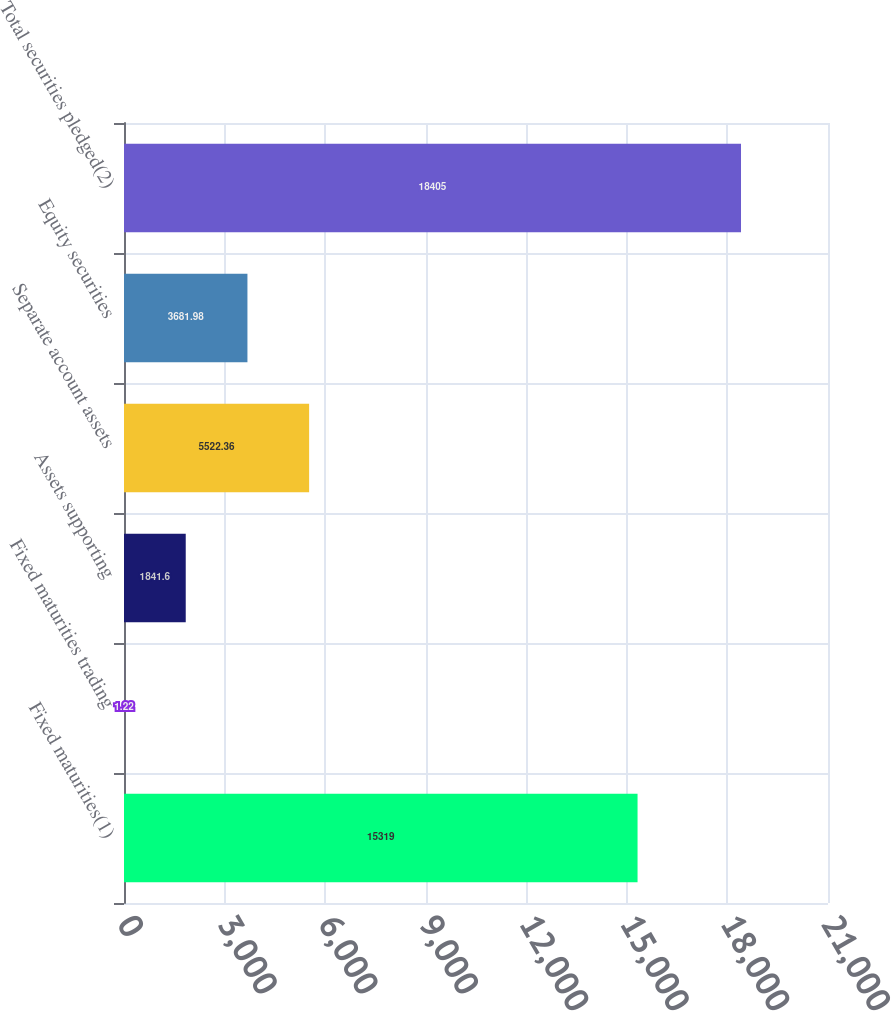Convert chart. <chart><loc_0><loc_0><loc_500><loc_500><bar_chart><fcel>Fixed maturities(1)<fcel>Fixed maturities trading<fcel>Assets supporting<fcel>Separate account assets<fcel>Equity securities<fcel>Total securities pledged(2)<nl><fcel>15319<fcel>1.22<fcel>1841.6<fcel>5522.36<fcel>3681.98<fcel>18405<nl></chart> 